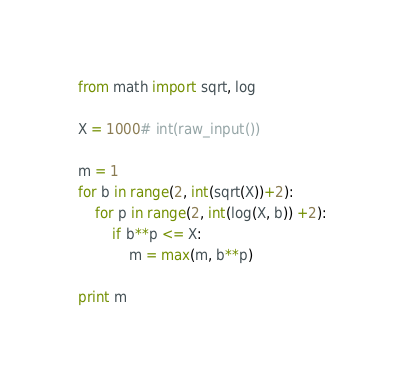Convert code to text. <code><loc_0><loc_0><loc_500><loc_500><_Python_>from math import sqrt, log

X = 1000# int(raw_input())

m = 1
for b in range(2, int(sqrt(X))+2):
    for p in range(2, int(log(X, b)) +2):
        if b**p <= X:
            m = max(m, b**p)

print m</code> 